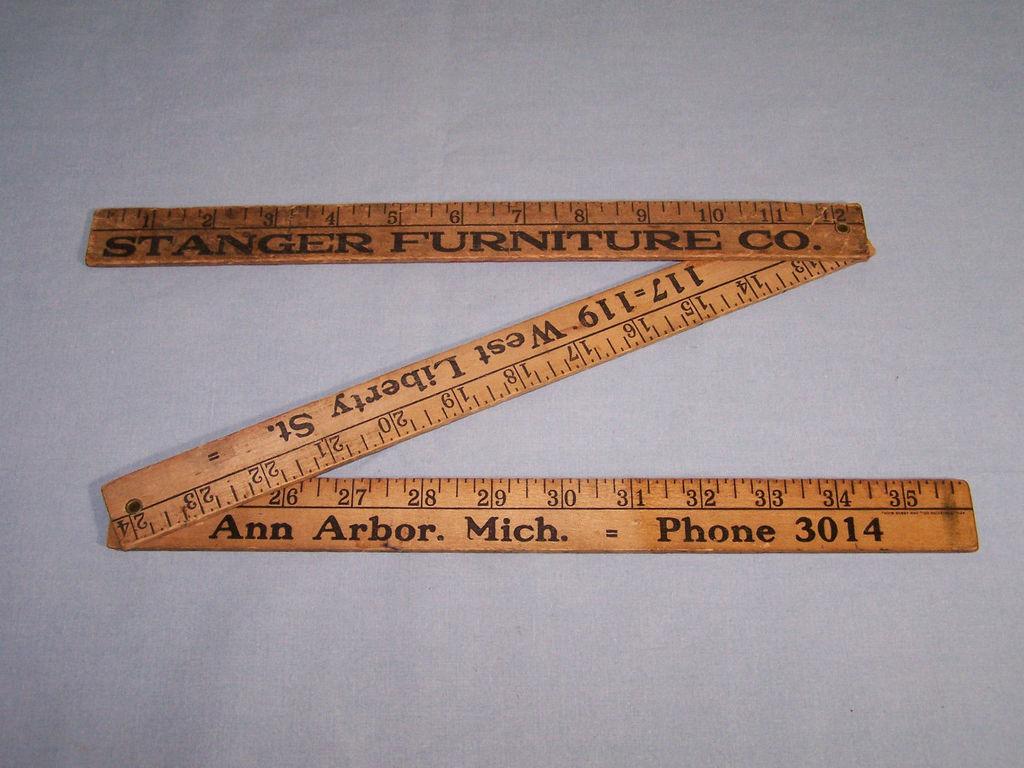What is the address on the ruler?
Offer a very short reply. 117-119 west liberty st. Who made the ruler?
Give a very brief answer. Stanger furniture co. 